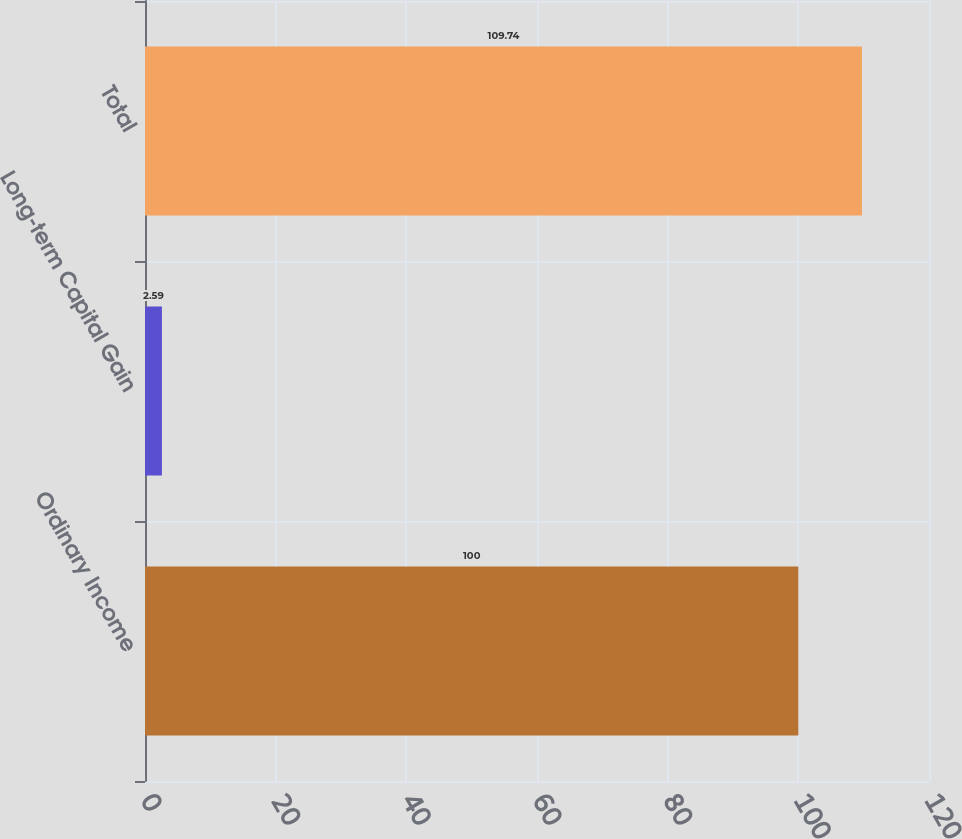Convert chart to OTSL. <chart><loc_0><loc_0><loc_500><loc_500><bar_chart><fcel>Ordinary Income<fcel>Long-term Capital Gain<fcel>Total<nl><fcel>100<fcel>2.59<fcel>109.74<nl></chart> 